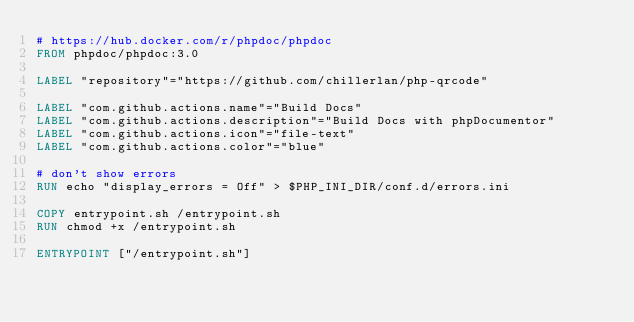<code> <loc_0><loc_0><loc_500><loc_500><_Dockerfile_># https://hub.docker.com/r/phpdoc/phpdoc
FROM phpdoc/phpdoc:3.0

LABEL "repository"="https://github.com/chillerlan/php-qrcode"

LABEL "com.github.actions.name"="Build Docs"
LABEL "com.github.actions.description"="Build Docs with phpDocumentor"
LABEL "com.github.actions.icon"="file-text"
LABEL "com.github.actions.color"="blue"

# don't show errors
RUN echo "display_errors = Off" > $PHP_INI_DIR/conf.d/errors.ini

COPY entrypoint.sh /entrypoint.sh
RUN chmod +x /entrypoint.sh

ENTRYPOINT ["/entrypoint.sh"]
</code> 